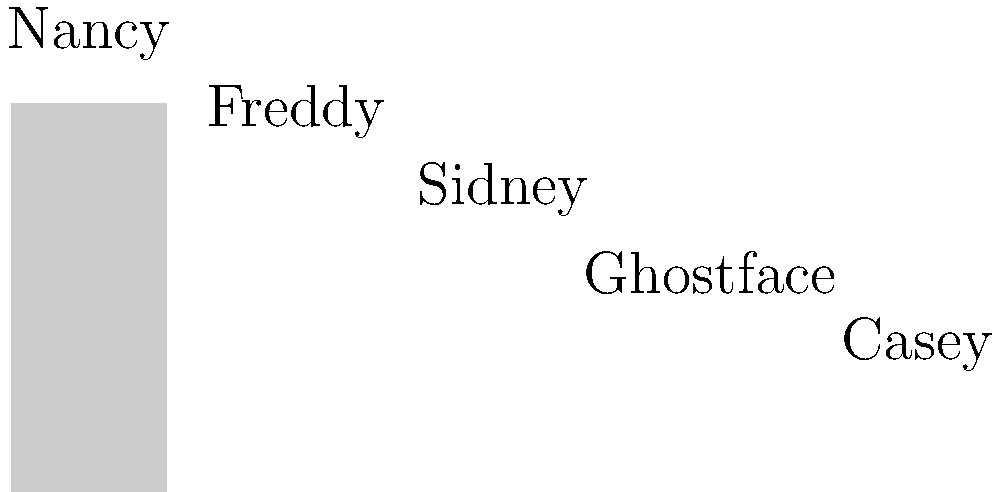In a facial recognition analysis of Wes Craven's films, the graph shows the screen time for various characters. If you were to implement a machine learning algorithm to track character appearances, which character would likely require the most training data to achieve accurate recognition, and why? To determine which character would require the most training data for accurate facial recognition, we need to consider the following factors:

1. Screen time: Characters with more screen time provide more facial data for the algorithm to learn from.
2. Facial variability: Characters with varying appearances or masks may require more diverse training data.

Analyzing the graph:
1. Nancy has the highest screen time (75 minutes).
2. Freddy has the second-highest screen time (60 minutes).
3. Sidney has 45 minutes of screen time.
4. Ghostface has 30 minutes of screen time.
5. Casey has the least screen time (15 minutes).

Despite having less screen time than Nancy, Ghostface would likely require the most training data because:
1. Ghostface wears a mask, which limits facial features for recognition.
2. Multiple characters portray Ghostface across different films, increasing variability.
3. The mask's appearance may change slightly between films or scenes.
4. Lighting conditions and angles can significantly affect the mask's appearance.

These factors increase the complexity of recognizing Ghostface consistently, necessitating more diverse training data to capture various mask appearances, lighting conditions, and potential variations between different actors portraying the character.
Answer: Ghostface 